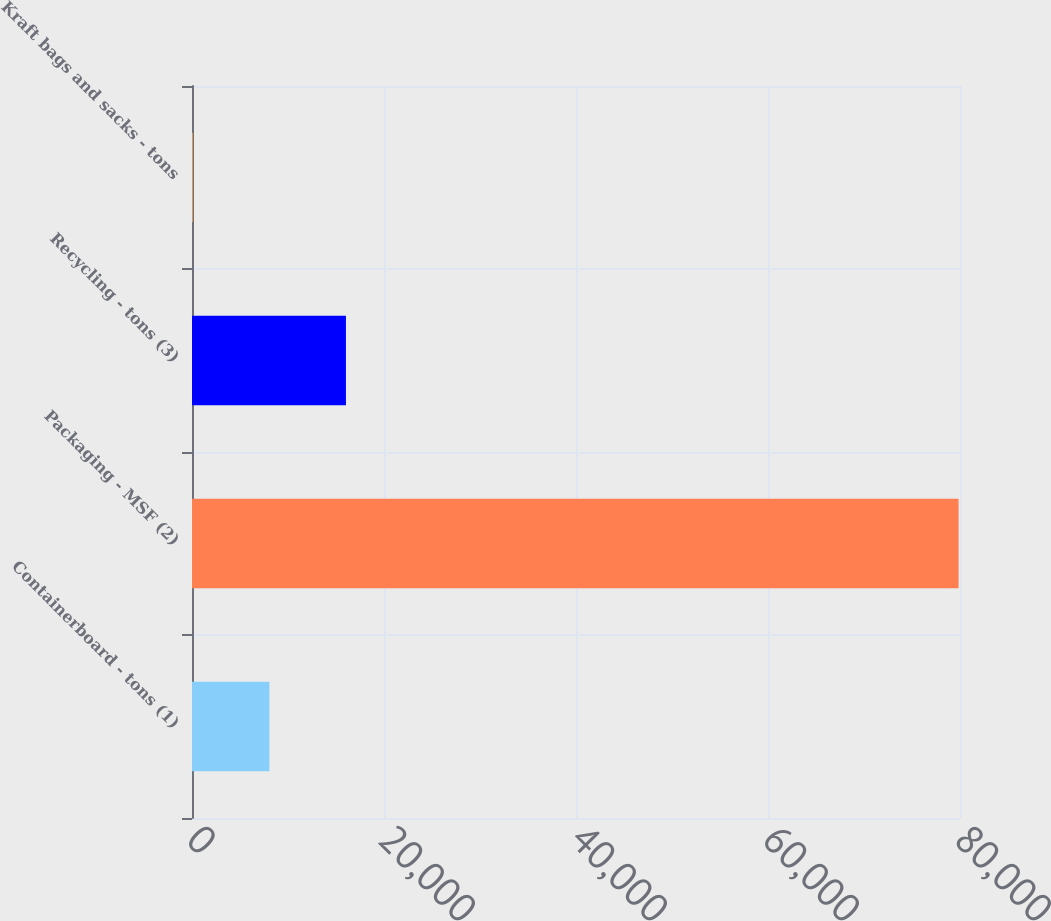<chart> <loc_0><loc_0><loc_500><loc_500><bar_chart><fcel>Containerboard - tons (1)<fcel>Packaging - MSF (2)<fcel>Recycling - tons (3)<fcel>Kraft bags and sacks - tons<nl><fcel>8058.9<fcel>79851<fcel>16035.8<fcel>82<nl></chart> 